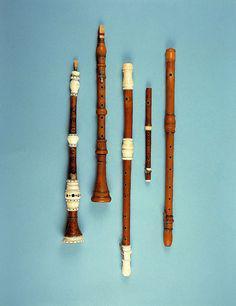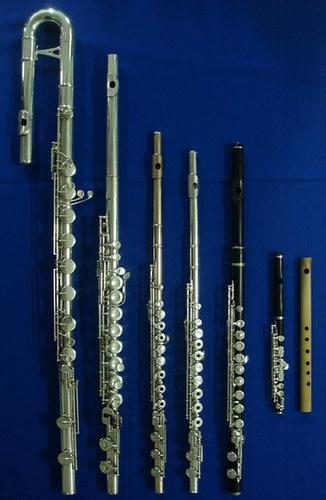The first image is the image on the left, the second image is the image on the right. For the images displayed, is the sentence "The left image contains at least three flute like musical instruments." factually correct? Answer yes or no. Yes. The first image is the image on the left, the second image is the image on the right. For the images displayed, is the sentence "There are more than three flutes." factually correct? Answer yes or no. Yes. 